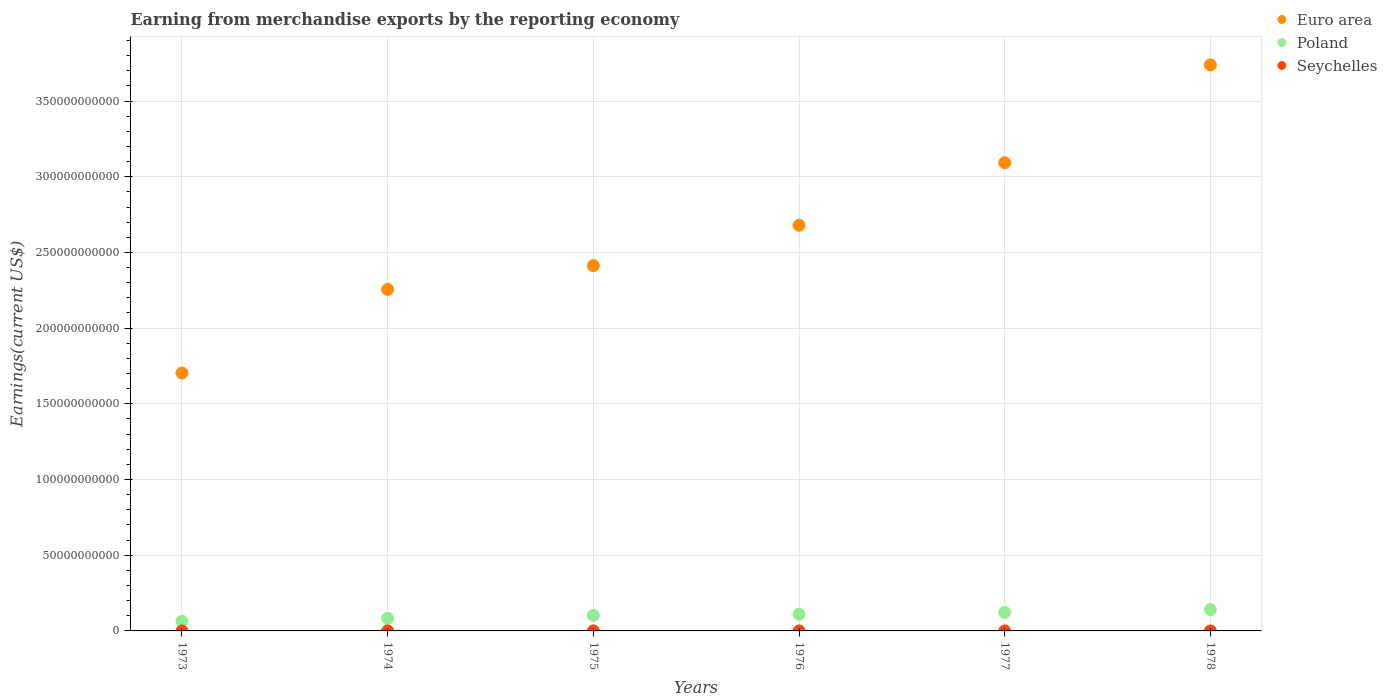Is the number of dotlines equal to the number of legend labels?
Keep it short and to the point. Yes. What is the amount earned from merchandise exports in Euro area in 1973?
Provide a short and direct response. 1.70e+11. Across all years, what is the maximum amount earned from merchandise exports in Poland?
Give a very brief answer. 1.41e+1. Across all years, what is the minimum amount earned from merchandise exports in Poland?
Your answer should be very brief. 6.43e+09. In which year was the amount earned from merchandise exports in Euro area maximum?
Offer a terse response. 1978. In which year was the amount earned from merchandise exports in Euro area minimum?
Provide a succinct answer. 1973. What is the total amount earned from merchandise exports in Poland in the graph?
Ensure brevity in your answer.  6.24e+1. What is the difference between the amount earned from merchandise exports in Seychelles in 1973 and that in 1976?
Ensure brevity in your answer.  3.00e+05. What is the difference between the amount earned from merchandise exports in Poland in 1978 and the amount earned from merchandise exports in Euro area in 1977?
Offer a terse response. -2.95e+11. What is the average amount earned from merchandise exports in Euro area per year?
Ensure brevity in your answer.  2.65e+11. In the year 1978, what is the difference between the amount earned from merchandise exports in Euro area and amount earned from merchandise exports in Poland?
Give a very brief answer. 3.60e+11. What is the ratio of the amount earned from merchandise exports in Seychelles in 1975 to that in 1976?
Provide a succinct answer. 1.18. What is the difference between the highest and the second highest amount earned from merchandise exports in Poland?
Keep it short and to the point. 1.85e+09. What is the difference between the highest and the lowest amount earned from merchandise exports in Seychelles?
Your answer should be compact. 1.12e+07. In how many years, is the amount earned from merchandise exports in Seychelles greater than the average amount earned from merchandise exports in Seychelles taken over all years?
Ensure brevity in your answer.  2. Is the sum of the amount earned from merchandise exports in Poland in 1974 and 1978 greater than the maximum amount earned from merchandise exports in Euro area across all years?
Give a very brief answer. No. How many dotlines are there?
Keep it short and to the point. 3. Does the graph contain grids?
Offer a terse response. Yes. How many legend labels are there?
Make the answer very short. 3. What is the title of the graph?
Keep it short and to the point. Earning from merchandise exports by the reporting economy. Does "Caribbean small states" appear as one of the legend labels in the graph?
Give a very brief answer. No. What is the label or title of the X-axis?
Ensure brevity in your answer.  Years. What is the label or title of the Y-axis?
Give a very brief answer. Earnings(current US$). What is the Earnings(current US$) in Euro area in 1973?
Make the answer very short. 1.70e+11. What is the Earnings(current US$) of Poland in 1973?
Offer a very short reply. 6.43e+09. What is the Earnings(current US$) of Seychelles in 1973?
Provide a short and direct response. 2.00e+06. What is the Earnings(current US$) of Euro area in 1974?
Provide a short and direct response. 2.26e+11. What is the Earnings(current US$) in Poland in 1974?
Your answer should be compact. 8.32e+09. What is the Earnings(current US$) in Seychelles in 1974?
Provide a short and direct response. 2.60e+06. What is the Earnings(current US$) in Euro area in 1975?
Provide a succinct answer. 2.41e+11. What is the Earnings(current US$) of Poland in 1975?
Provide a succinct answer. 1.03e+1. What is the Earnings(current US$) of Seychelles in 1975?
Your answer should be compact. 2.00e+06. What is the Earnings(current US$) of Euro area in 1976?
Provide a short and direct response. 2.68e+11. What is the Earnings(current US$) in Poland in 1976?
Offer a terse response. 1.10e+1. What is the Earnings(current US$) in Seychelles in 1976?
Provide a succinct answer. 1.70e+06. What is the Earnings(current US$) in Euro area in 1977?
Provide a short and direct response. 3.09e+11. What is the Earnings(current US$) of Poland in 1977?
Provide a succinct answer. 1.23e+1. What is the Earnings(current US$) of Seychelles in 1977?
Make the answer very short. 9.60e+06. What is the Earnings(current US$) of Euro area in 1978?
Offer a very short reply. 3.74e+11. What is the Earnings(current US$) in Poland in 1978?
Offer a very short reply. 1.41e+1. What is the Earnings(current US$) in Seychelles in 1978?
Your answer should be very brief. 1.29e+07. Across all years, what is the maximum Earnings(current US$) in Euro area?
Give a very brief answer. 3.74e+11. Across all years, what is the maximum Earnings(current US$) in Poland?
Offer a very short reply. 1.41e+1. Across all years, what is the maximum Earnings(current US$) of Seychelles?
Make the answer very short. 1.29e+07. Across all years, what is the minimum Earnings(current US$) in Euro area?
Provide a succinct answer. 1.70e+11. Across all years, what is the minimum Earnings(current US$) in Poland?
Make the answer very short. 6.43e+09. Across all years, what is the minimum Earnings(current US$) of Seychelles?
Provide a short and direct response. 1.70e+06. What is the total Earnings(current US$) of Euro area in the graph?
Provide a succinct answer. 1.59e+12. What is the total Earnings(current US$) in Poland in the graph?
Offer a very short reply. 6.24e+1. What is the total Earnings(current US$) of Seychelles in the graph?
Your answer should be compact. 3.08e+07. What is the difference between the Earnings(current US$) in Euro area in 1973 and that in 1974?
Keep it short and to the point. -5.52e+1. What is the difference between the Earnings(current US$) in Poland in 1973 and that in 1974?
Provide a short and direct response. -1.89e+09. What is the difference between the Earnings(current US$) of Seychelles in 1973 and that in 1974?
Give a very brief answer. -6.00e+05. What is the difference between the Earnings(current US$) in Euro area in 1973 and that in 1975?
Keep it short and to the point. -7.09e+1. What is the difference between the Earnings(current US$) of Poland in 1973 and that in 1975?
Give a very brief answer. -3.85e+09. What is the difference between the Earnings(current US$) of Euro area in 1973 and that in 1976?
Offer a terse response. -9.76e+1. What is the difference between the Earnings(current US$) in Poland in 1973 and that in 1976?
Offer a terse response. -4.58e+09. What is the difference between the Earnings(current US$) of Seychelles in 1973 and that in 1976?
Give a very brief answer. 3.00e+05. What is the difference between the Earnings(current US$) in Euro area in 1973 and that in 1977?
Ensure brevity in your answer.  -1.39e+11. What is the difference between the Earnings(current US$) in Poland in 1973 and that in 1977?
Provide a short and direct response. -5.83e+09. What is the difference between the Earnings(current US$) of Seychelles in 1973 and that in 1977?
Offer a very short reply. -7.60e+06. What is the difference between the Earnings(current US$) of Euro area in 1973 and that in 1978?
Your response must be concise. -2.04e+11. What is the difference between the Earnings(current US$) of Poland in 1973 and that in 1978?
Ensure brevity in your answer.  -7.68e+09. What is the difference between the Earnings(current US$) in Seychelles in 1973 and that in 1978?
Your answer should be compact. -1.09e+07. What is the difference between the Earnings(current US$) in Euro area in 1974 and that in 1975?
Your answer should be compact. -1.57e+1. What is the difference between the Earnings(current US$) in Poland in 1974 and that in 1975?
Keep it short and to the point. -1.96e+09. What is the difference between the Earnings(current US$) in Seychelles in 1974 and that in 1975?
Ensure brevity in your answer.  6.00e+05. What is the difference between the Earnings(current US$) in Euro area in 1974 and that in 1976?
Provide a short and direct response. -4.24e+1. What is the difference between the Earnings(current US$) of Poland in 1974 and that in 1976?
Offer a very short reply. -2.70e+09. What is the difference between the Earnings(current US$) of Euro area in 1974 and that in 1977?
Your answer should be very brief. -8.37e+1. What is the difference between the Earnings(current US$) of Poland in 1974 and that in 1977?
Offer a terse response. -3.94e+09. What is the difference between the Earnings(current US$) of Seychelles in 1974 and that in 1977?
Provide a short and direct response. -7.00e+06. What is the difference between the Earnings(current US$) of Euro area in 1974 and that in 1978?
Your answer should be compact. -1.48e+11. What is the difference between the Earnings(current US$) of Poland in 1974 and that in 1978?
Give a very brief answer. -5.79e+09. What is the difference between the Earnings(current US$) of Seychelles in 1974 and that in 1978?
Your answer should be very brief. -1.03e+07. What is the difference between the Earnings(current US$) in Euro area in 1975 and that in 1976?
Your answer should be compact. -2.67e+1. What is the difference between the Earnings(current US$) in Poland in 1975 and that in 1976?
Ensure brevity in your answer.  -7.34e+08. What is the difference between the Earnings(current US$) of Seychelles in 1975 and that in 1976?
Ensure brevity in your answer.  3.00e+05. What is the difference between the Earnings(current US$) of Euro area in 1975 and that in 1977?
Offer a terse response. -6.80e+1. What is the difference between the Earnings(current US$) in Poland in 1975 and that in 1977?
Your answer should be compact. -1.98e+09. What is the difference between the Earnings(current US$) in Seychelles in 1975 and that in 1977?
Provide a short and direct response. -7.60e+06. What is the difference between the Earnings(current US$) in Euro area in 1975 and that in 1978?
Make the answer very short. -1.33e+11. What is the difference between the Earnings(current US$) in Poland in 1975 and that in 1978?
Provide a succinct answer. -3.83e+09. What is the difference between the Earnings(current US$) of Seychelles in 1975 and that in 1978?
Offer a very short reply. -1.09e+07. What is the difference between the Earnings(current US$) in Euro area in 1976 and that in 1977?
Your response must be concise. -4.13e+1. What is the difference between the Earnings(current US$) in Poland in 1976 and that in 1977?
Give a very brief answer. -1.25e+09. What is the difference between the Earnings(current US$) of Seychelles in 1976 and that in 1977?
Offer a very short reply. -7.90e+06. What is the difference between the Earnings(current US$) in Euro area in 1976 and that in 1978?
Your response must be concise. -1.06e+11. What is the difference between the Earnings(current US$) in Poland in 1976 and that in 1978?
Provide a succinct answer. -3.10e+09. What is the difference between the Earnings(current US$) of Seychelles in 1976 and that in 1978?
Provide a short and direct response. -1.12e+07. What is the difference between the Earnings(current US$) of Euro area in 1977 and that in 1978?
Your answer should be compact. -6.46e+1. What is the difference between the Earnings(current US$) in Poland in 1977 and that in 1978?
Your response must be concise. -1.85e+09. What is the difference between the Earnings(current US$) of Seychelles in 1977 and that in 1978?
Give a very brief answer. -3.30e+06. What is the difference between the Earnings(current US$) in Euro area in 1973 and the Earnings(current US$) in Poland in 1974?
Ensure brevity in your answer.  1.62e+11. What is the difference between the Earnings(current US$) of Euro area in 1973 and the Earnings(current US$) of Seychelles in 1974?
Keep it short and to the point. 1.70e+11. What is the difference between the Earnings(current US$) of Poland in 1973 and the Earnings(current US$) of Seychelles in 1974?
Your answer should be compact. 6.43e+09. What is the difference between the Earnings(current US$) in Euro area in 1973 and the Earnings(current US$) in Poland in 1975?
Offer a terse response. 1.60e+11. What is the difference between the Earnings(current US$) of Euro area in 1973 and the Earnings(current US$) of Seychelles in 1975?
Offer a terse response. 1.70e+11. What is the difference between the Earnings(current US$) in Poland in 1973 and the Earnings(current US$) in Seychelles in 1975?
Keep it short and to the point. 6.43e+09. What is the difference between the Earnings(current US$) in Euro area in 1973 and the Earnings(current US$) in Poland in 1976?
Your answer should be compact. 1.59e+11. What is the difference between the Earnings(current US$) of Euro area in 1973 and the Earnings(current US$) of Seychelles in 1976?
Ensure brevity in your answer.  1.70e+11. What is the difference between the Earnings(current US$) in Poland in 1973 and the Earnings(current US$) in Seychelles in 1976?
Your answer should be compact. 6.43e+09. What is the difference between the Earnings(current US$) in Euro area in 1973 and the Earnings(current US$) in Poland in 1977?
Your response must be concise. 1.58e+11. What is the difference between the Earnings(current US$) in Euro area in 1973 and the Earnings(current US$) in Seychelles in 1977?
Your answer should be very brief. 1.70e+11. What is the difference between the Earnings(current US$) in Poland in 1973 and the Earnings(current US$) in Seychelles in 1977?
Offer a terse response. 6.42e+09. What is the difference between the Earnings(current US$) in Euro area in 1973 and the Earnings(current US$) in Poland in 1978?
Offer a terse response. 1.56e+11. What is the difference between the Earnings(current US$) in Euro area in 1973 and the Earnings(current US$) in Seychelles in 1978?
Offer a very short reply. 1.70e+11. What is the difference between the Earnings(current US$) of Poland in 1973 and the Earnings(current US$) of Seychelles in 1978?
Your answer should be compact. 6.42e+09. What is the difference between the Earnings(current US$) in Euro area in 1974 and the Earnings(current US$) in Poland in 1975?
Ensure brevity in your answer.  2.15e+11. What is the difference between the Earnings(current US$) in Euro area in 1974 and the Earnings(current US$) in Seychelles in 1975?
Provide a succinct answer. 2.26e+11. What is the difference between the Earnings(current US$) in Poland in 1974 and the Earnings(current US$) in Seychelles in 1975?
Make the answer very short. 8.32e+09. What is the difference between the Earnings(current US$) of Euro area in 1974 and the Earnings(current US$) of Poland in 1976?
Your response must be concise. 2.15e+11. What is the difference between the Earnings(current US$) in Euro area in 1974 and the Earnings(current US$) in Seychelles in 1976?
Provide a short and direct response. 2.26e+11. What is the difference between the Earnings(current US$) of Poland in 1974 and the Earnings(current US$) of Seychelles in 1976?
Your response must be concise. 8.32e+09. What is the difference between the Earnings(current US$) of Euro area in 1974 and the Earnings(current US$) of Poland in 1977?
Provide a succinct answer. 2.13e+11. What is the difference between the Earnings(current US$) of Euro area in 1974 and the Earnings(current US$) of Seychelles in 1977?
Your answer should be very brief. 2.26e+11. What is the difference between the Earnings(current US$) of Poland in 1974 and the Earnings(current US$) of Seychelles in 1977?
Offer a terse response. 8.31e+09. What is the difference between the Earnings(current US$) in Euro area in 1974 and the Earnings(current US$) in Poland in 1978?
Offer a terse response. 2.11e+11. What is the difference between the Earnings(current US$) of Euro area in 1974 and the Earnings(current US$) of Seychelles in 1978?
Your answer should be compact. 2.26e+11. What is the difference between the Earnings(current US$) in Poland in 1974 and the Earnings(current US$) in Seychelles in 1978?
Give a very brief answer. 8.31e+09. What is the difference between the Earnings(current US$) in Euro area in 1975 and the Earnings(current US$) in Poland in 1976?
Your response must be concise. 2.30e+11. What is the difference between the Earnings(current US$) of Euro area in 1975 and the Earnings(current US$) of Seychelles in 1976?
Your answer should be very brief. 2.41e+11. What is the difference between the Earnings(current US$) in Poland in 1975 and the Earnings(current US$) in Seychelles in 1976?
Provide a short and direct response. 1.03e+1. What is the difference between the Earnings(current US$) in Euro area in 1975 and the Earnings(current US$) in Poland in 1977?
Offer a terse response. 2.29e+11. What is the difference between the Earnings(current US$) in Euro area in 1975 and the Earnings(current US$) in Seychelles in 1977?
Provide a succinct answer. 2.41e+11. What is the difference between the Earnings(current US$) in Poland in 1975 and the Earnings(current US$) in Seychelles in 1977?
Your answer should be very brief. 1.03e+1. What is the difference between the Earnings(current US$) in Euro area in 1975 and the Earnings(current US$) in Poland in 1978?
Provide a short and direct response. 2.27e+11. What is the difference between the Earnings(current US$) in Euro area in 1975 and the Earnings(current US$) in Seychelles in 1978?
Provide a short and direct response. 2.41e+11. What is the difference between the Earnings(current US$) in Poland in 1975 and the Earnings(current US$) in Seychelles in 1978?
Make the answer very short. 1.03e+1. What is the difference between the Earnings(current US$) in Euro area in 1976 and the Earnings(current US$) in Poland in 1977?
Provide a succinct answer. 2.56e+11. What is the difference between the Earnings(current US$) of Euro area in 1976 and the Earnings(current US$) of Seychelles in 1977?
Keep it short and to the point. 2.68e+11. What is the difference between the Earnings(current US$) in Poland in 1976 and the Earnings(current US$) in Seychelles in 1977?
Keep it short and to the point. 1.10e+1. What is the difference between the Earnings(current US$) of Euro area in 1976 and the Earnings(current US$) of Poland in 1978?
Your answer should be compact. 2.54e+11. What is the difference between the Earnings(current US$) in Euro area in 1976 and the Earnings(current US$) in Seychelles in 1978?
Your answer should be very brief. 2.68e+11. What is the difference between the Earnings(current US$) in Poland in 1976 and the Earnings(current US$) in Seychelles in 1978?
Ensure brevity in your answer.  1.10e+1. What is the difference between the Earnings(current US$) of Euro area in 1977 and the Earnings(current US$) of Poland in 1978?
Offer a terse response. 2.95e+11. What is the difference between the Earnings(current US$) of Euro area in 1977 and the Earnings(current US$) of Seychelles in 1978?
Your answer should be compact. 3.09e+11. What is the difference between the Earnings(current US$) of Poland in 1977 and the Earnings(current US$) of Seychelles in 1978?
Your answer should be compact. 1.23e+1. What is the average Earnings(current US$) of Euro area per year?
Offer a terse response. 2.65e+11. What is the average Earnings(current US$) in Poland per year?
Make the answer very short. 1.04e+1. What is the average Earnings(current US$) of Seychelles per year?
Your answer should be compact. 5.13e+06. In the year 1973, what is the difference between the Earnings(current US$) of Euro area and Earnings(current US$) of Poland?
Offer a very short reply. 1.64e+11. In the year 1973, what is the difference between the Earnings(current US$) in Euro area and Earnings(current US$) in Seychelles?
Your response must be concise. 1.70e+11. In the year 1973, what is the difference between the Earnings(current US$) of Poland and Earnings(current US$) of Seychelles?
Offer a very short reply. 6.43e+09. In the year 1974, what is the difference between the Earnings(current US$) in Euro area and Earnings(current US$) in Poland?
Ensure brevity in your answer.  2.17e+11. In the year 1974, what is the difference between the Earnings(current US$) in Euro area and Earnings(current US$) in Seychelles?
Offer a terse response. 2.26e+11. In the year 1974, what is the difference between the Earnings(current US$) in Poland and Earnings(current US$) in Seychelles?
Offer a terse response. 8.32e+09. In the year 1975, what is the difference between the Earnings(current US$) in Euro area and Earnings(current US$) in Poland?
Your answer should be compact. 2.31e+11. In the year 1975, what is the difference between the Earnings(current US$) of Euro area and Earnings(current US$) of Seychelles?
Offer a very short reply. 2.41e+11. In the year 1975, what is the difference between the Earnings(current US$) of Poland and Earnings(current US$) of Seychelles?
Make the answer very short. 1.03e+1. In the year 1976, what is the difference between the Earnings(current US$) in Euro area and Earnings(current US$) in Poland?
Make the answer very short. 2.57e+11. In the year 1976, what is the difference between the Earnings(current US$) in Euro area and Earnings(current US$) in Seychelles?
Keep it short and to the point. 2.68e+11. In the year 1976, what is the difference between the Earnings(current US$) of Poland and Earnings(current US$) of Seychelles?
Provide a succinct answer. 1.10e+1. In the year 1977, what is the difference between the Earnings(current US$) in Euro area and Earnings(current US$) in Poland?
Offer a very short reply. 2.97e+11. In the year 1977, what is the difference between the Earnings(current US$) in Euro area and Earnings(current US$) in Seychelles?
Your answer should be very brief. 3.09e+11. In the year 1977, what is the difference between the Earnings(current US$) of Poland and Earnings(current US$) of Seychelles?
Make the answer very short. 1.23e+1. In the year 1978, what is the difference between the Earnings(current US$) of Euro area and Earnings(current US$) of Poland?
Offer a very short reply. 3.60e+11. In the year 1978, what is the difference between the Earnings(current US$) in Euro area and Earnings(current US$) in Seychelles?
Ensure brevity in your answer.  3.74e+11. In the year 1978, what is the difference between the Earnings(current US$) of Poland and Earnings(current US$) of Seychelles?
Provide a succinct answer. 1.41e+1. What is the ratio of the Earnings(current US$) in Euro area in 1973 to that in 1974?
Give a very brief answer. 0.76. What is the ratio of the Earnings(current US$) in Poland in 1973 to that in 1974?
Offer a terse response. 0.77. What is the ratio of the Earnings(current US$) of Seychelles in 1973 to that in 1974?
Your answer should be very brief. 0.77. What is the ratio of the Earnings(current US$) in Euro area in 1973 to that in 1975?
Keep it short and to the point. 0.71. What is the ratio of the Earnings(current US$) of Poland in 1973 to that in 1975?
Provide a short and direct response. 0.63. What is the ratio of the Earnings(current US$) in Seychelles in 1973 to that in 1975?
Your answer should be compact. 1. What is the ratio of the Earnings(current US$) in Euro area in 1973 to that in 1976?
Offer a terse response. 0.64. What is the ratio of the Earnings(current US$) of Poland in 1973 to that in 1976?
Ensure brevity in your answer.  0.58. What is the ratio of the Earnings(current US$) in Seychelles in 1973 to that in 1976?
Provide a succinct answer. 1.18. What is the ratio of the Earnings(current US$) in Euro area in 1973 to that in 1977?
Your answer should be very brief. 0.55. What is the ratio of the Earnings(current US$) of Poland in 1973 to that in 1977?
Your answer should be compact. 0.52. What is the ratio of the Earnings(current US$) of Seychelles in 1973 to that in 1977?
Ensure brevity in your answer.  0.21. What is the ratio of the Earnings(current US$) of Euro area in 1973 to that in 1978?
Keep it short and to the point. 0.46. What is the ratio of the Earnings(current US$) of Poland in 1973 to that in 1978?
Offer a very short reply. 0.46. What is the ratio of the Earnings(current US$) in Seychelles in 1973 to that in 1978?
Provide a succinct answer. 0.15. What is the ratio of the Earnings(current US$) of Euro area in 1974 to that in 1975?
Your response must be concise. 0.93. What is the ratio of the Earnings(current US$) in Poland in 1974 to that in 1975?
Make the answer very short. 0.81. What is the ratio of the Earnings(current US$) of Euro area in 1974 to that in 1976?
Ensure brevity in your answer.  0.84. What is the ratio of the Earnings(current US$) of Poland in 1974 to that in 1976?
Ensure brevity in your answer.  0.76. What is the ratio of the Earnings(current US$) in Seychelles in 1974 to that in 1976?
Keep it short and to the point. 1.53. What is the ratio of the Earnings(current US$) of Euro area in 1974 to that in 1977?
Provide a succinct answer. 0.73. What is the ratio of the Earnings(current US$) of Poland in 1974 to that in 1977?
Your response must be concise. 0.68. What is the ratio of the Earnings(current US$) of Seychelles in 1974 to that in 1977?
Provide a short and direct response. 0.27. What is the ratio of the Earnings(current US$) of Euro area in 1974 to that in 1978?
Offer a terse response. 0.6. What is the ratio of the Earnings(current US$) in Poland in 1974 to that in 1978?
Make the answer very short. 0.59. What is the ratio of the Earnings(current US$) in Seychelles in 1974 to that in 1978?
Give a very brief answer. 0.2. What is the ratio of the Earnings(current US$) in Euro area in 1975 to that in 1976?
Your response must be concise. 0.9. What is the ratio of the Earnings(current US$) in Seychelles in 1975 to that in 1976?
Your response must be concise. 1.18. What is the ratio of the Earnings(current US$) in Euro area in 1975 to that in 1977?
Provide a succinct answer. 0.78. What is the ratio of the Earnings(current US$) in Poland in 1975 to that in 1977?
Give a very brief answer. 0.84. What is the ratio of the Earnings(current US$) of Seychelles in 1975 to that in 1977?
Give a very brief answer. 0.21. What is the ratio of the Earnings(current US$) of Euro area in 1975 to that in 1978?
Make the answer very short. 0.65. What is the ratio of the Earnings(current US$) in Poland in 1975 to that in 1978?
Your answer should be very brief. 0.73. What is the ratio of the Earnings(current US$) of Seychelles in 1975 to that in 1978?
Provide a succinct answer. 0.15. What is the ratio of the Earnings(current US$) of Euro area in 1976 to that in 1977?
Ensure brevity in your answer.  0.87. What is the ratio of the Earnings(current US$) in Poland in 1976 to that in 1977?
Make the answer very short. 0.9. What is the ratio of the Earnings(current US$) of Seychelles in 1976 to that in 1977?
Offer a terse response. 0.18. What is the ratio of the Earnings(current US$) of Euro area in 1976 to that in 1978?
Your answer should be compact. 0.72. What is the ratio of the Earnings(current US$) of Poland in 1976 to that in 1978?
Make the answer very short. 0.78. What is the ratio of the Earnings(current US$) in Seychelles in 1976 to that in 1978?
Keep it short and to the point. 0.13. What is the ratio of the Earnings(current US$) in Euro area in 1977 to that in 1978?
Your answer should be very brief. 0.83. What is the ratio of the Earnings(current US$) of Poland in 1977 to that in 1978?
Your answer should be very brief. 0.87. What is the ratio of the Earnings(current US$) of Seychelles in 1977 to that in 1978?
Your response must be concise. 0.74. What is the difference between the highest and the second highest Earnings(current US$) in Euro area?
Make the answer very short. 6.46e+1. What is the difference between the highest and the second highest Earnings(current US$) in Poland?
Your answer should be very brief. 1.85e+09. What is the difference between the highest and the second highest Earnings(current US$) of Seychelles?
Give a very brief answer. 3.30e+06. What is the difference between the highest and the lowest Earnings(current US$) in Euro area?
Keep it short and to the point. 2.04e+11. What is the difference between the highest and the lowest Earnings(current US$) in Poland?
Provide a succinct answer. 7.68e+09. What is the difference between the highest and the lowest Earnings(current US$) of Seychelles?
Make the answer very short. 1.12e+07. 